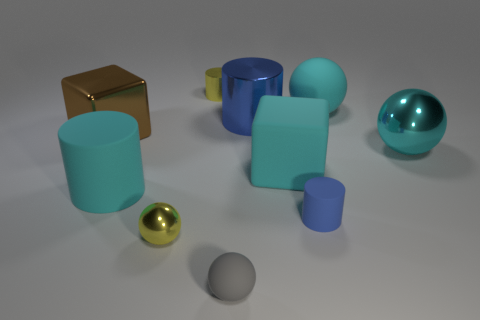If this scene were part of a larger story, what role might these objects play? In a larger narrative, these objects could represent a set of mystical elements that each carry unique properties or powers. The golden sphere, for instance, might be the central artifact of importance, with the cyan objects acting as protectors or keys to unlock its secrets. 